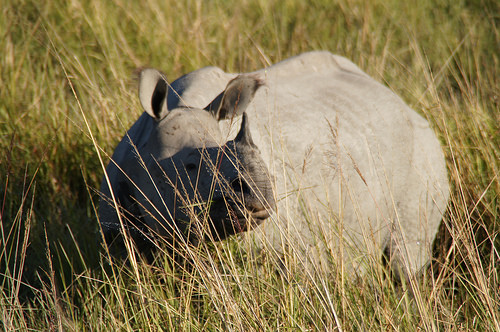<image>
Is there a rhino in front of the grass? No. The rhino is not in front of the grass. The spatial positioning shows a different relationship between these objects. 